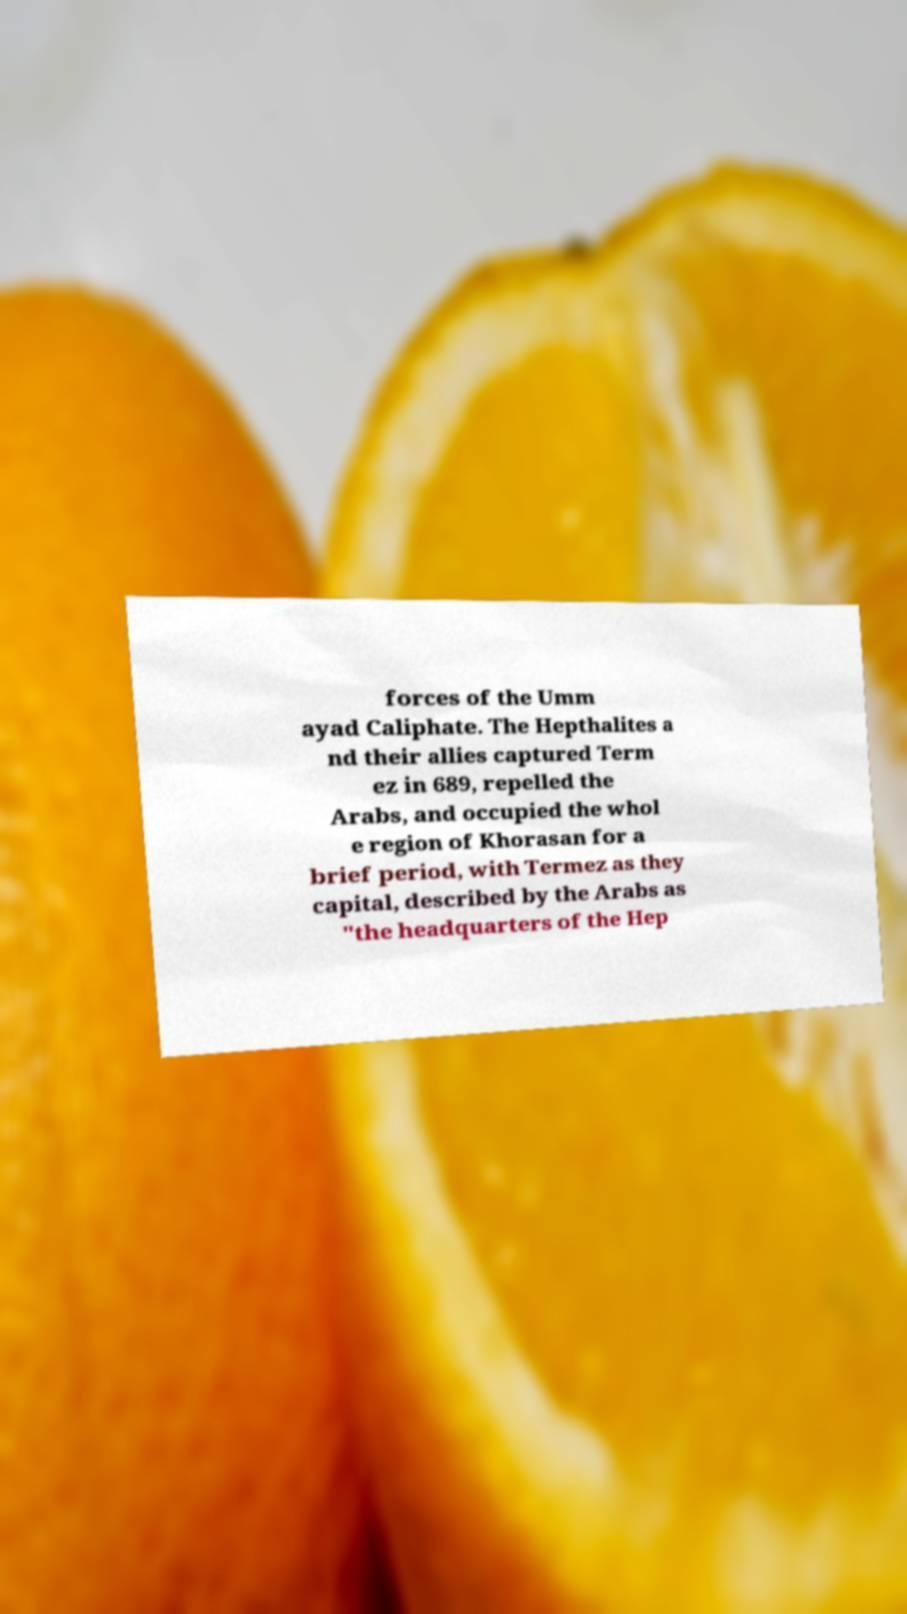Can you accurately transcribe the text from the provided image for me? forces of the Umm ayad Caliphate. The Hepthalites a nd their allies captured Term ez in 689, repelled the Arabs, and occupied the whol e region of Khorasan for a brief period, with Termez as they capital, described by the Arabs as "the headquarters of the Hep 